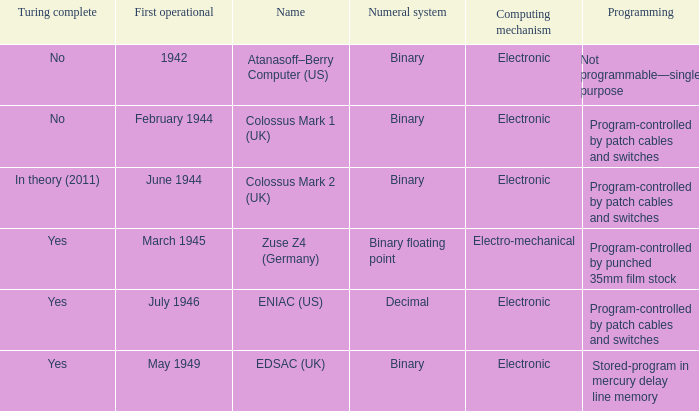What's the computing mechanbeingm with first operational being february 1944 Electronic. 